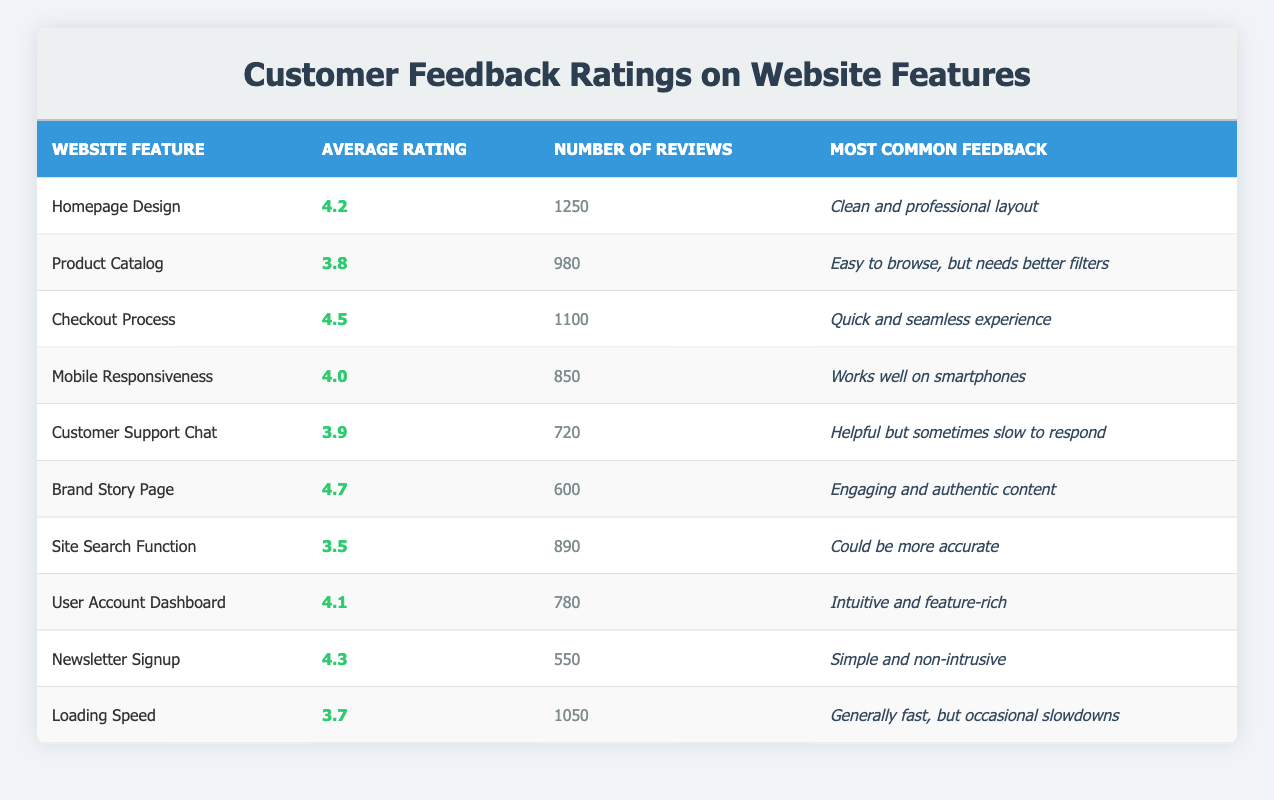What is the average rating for the 'Checkout Process'? The average rating is listed directly in the table under the 'Average Rating' column for the 'Checkout Process' row. It shows a rating of 4.5.
Answer: 4.5 Which website feature has the most reviews? By examining the 'Number of Reviews' column, we see that 'Homepage Design' has the highest number of reviews at 1250.
Answer: Homepage Design Is the average rating for the 'Loading Speed' feature above 4.0? The average rating for 'Loading Speed' is 3.7, which is below 4.0. Therefore, the statement is false.
Answer: No What is the difference in average ratings between the 'Brand Story Page' and the 'Site Search Function'? The average rating for the 'Brand Story Page' is 4.7 and for the 'Site Search Function' is 3.5. To find the difference, subtract 3.5 from 4.7 which equals 1.2.
Answer: 1.2 Which feature has a higher rating: 'Mobile Responsiveness' or 'User Account Dashboard'? 'Mobile Responsiveness' has an average rating of 4.0 while 'User Account Dashboard' has 4.1. Since 4.1 is greater than 4.0, 'User Account Dashboard' has the higher rating.
Answer: User Account Dashboard How many features have an average rating of 4.0 or higher? By reviewing the ratings, the features with an average rating of 4.0 or higher are: 'Homepage Design', 'Checkout Process', 'Mobile Responsiveness', 'Brand Story Page', 'User Account Dashboard', and 'Newsletter Signup'. There are a total of 6 features that meet this criterion.
Answer: 6 Is the common feedback for 'Customer Support Chat' more positive than that for 'Product Catalog'? The feedback for 'Customer Support Chat' mentions it is "Helpful but sometimes slow to respond" whereas the feedback for 'Product Catalog' states it's "Easy to browse, but needs better filters." The Product Catalog feedback is more favorable as it focuses on browsing ease.
Answer: No What is the total number of reviews for features with a rating of 4.0 or higher? The features with ratings of 4.0 or higher are: 'Homepage Design' (1250), 'Checkout Process' (1100), 'Brand Story Page' (600), 'User Account Dashboard' (780), and 'Newsletter Signup' (550). Summing these gives: 1250 + 1100 + 600 + 780 + 550 = 4280.
Answer: 4280 